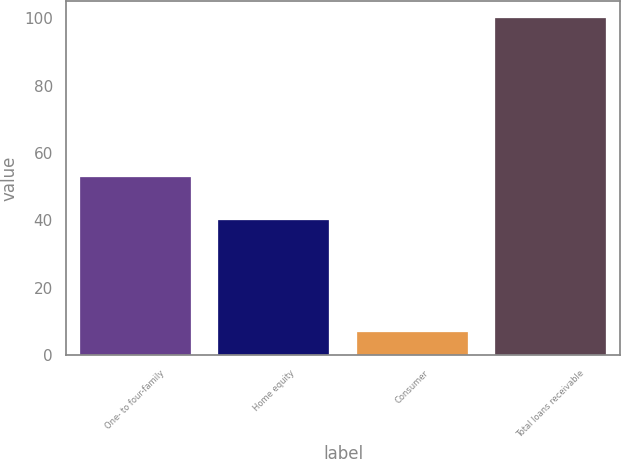Convert chart to OTSL. <chart><loc_0><loc_0><loc_500><loc_500><bar_chart><fcel>One- to four-family<fcel>Home equity<fcel>Consumer<fcel>Total loans receivable<nl><fcel>53<fcel>40<fcel>7<fcel>100<nl></chart> 